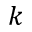Convert formula to latex. <formula><loc_0><loc_0><loc_500><loc_500>k</formula> 